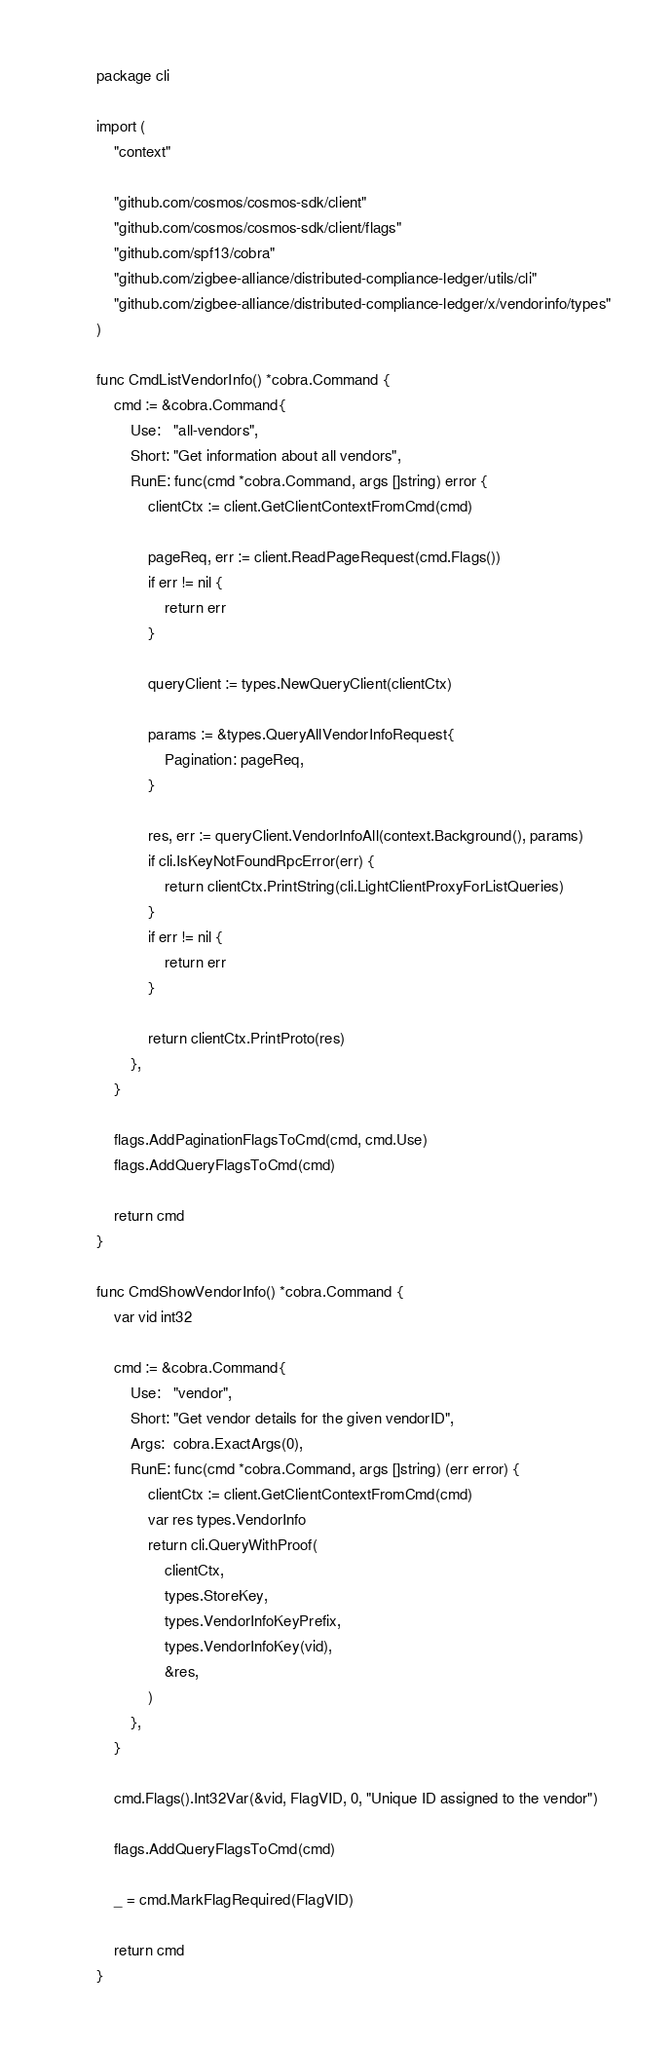<code> <loc_0><loc_0><loc_500><loc_500><_Go_>package cli

import (
	"context"

	"github.com/cosmos/cosmos-sdk/client"
	"github.com/cosmos/cosmos-sdk/client/flags"
	"github.com/spf13/cobra"
	"github.com/zigbee-alliance/distributed-compliance-ledger/utils/cli"
	"github.com/zigbee-alliance/distributed-compliance-ledger/x/vendorinfo/types"
)

func CmdListVendorInfo() *cobra.Command {
	cmd := &cobra.Command{
		Use:   "all-vendors",
		Short: "Get information about all vendors",
		RunE: func(cmd *cobra.Command, args []string) error {
			clientCtx := client.GetClientContextFromCmd(cmd)

			pageReq, err := client.ReadPageRequest(cmd.Flags())
			if err != nil {
				return err
			}

			queryClient := types.NewQueryClient(clientCtx)

			params := &types.QueryAllVendorInfoRequest{
				Pagination: pageReq,
			}

			res, err := queryClient.VendorInfoAll(context.Background(), params)
			if cli.IsKeyNotFoundRpcError(err) {
				return clientCtx.PrintString(cli.LightClientProxyForListQueries)
			}
			if err != nil {
				return err
			}

			return clientCtx.PrintProto(res)
		},
	}

	flags.AddPaginationFlagsToCmd(cmd, cmd.Use)
	flags.AddQueryFlagsToCmd(cmd)

	return cmd
}

func CmdShowVendorInfo() *cobra.Command {
	var vid int32

	cmd := &cobra.Command{
		Use:   "vendor",
		Short: "Get vendor details for the given vendorID",
		Args:  cobra.ExactArgs(0),
		RunE: func(cmd *cobra.Command, args []string) (err error) {
			clientCtx := client.GetClientContextFromCmd(cmd)
			var res types.VendorInfo
			return cli.QueryWithProof(
				clientCtx,
				types.StoreKey,
				types.VendorInfoKeyPrefix,
				types.VendorInfoKey(vid),
				&res,
			)
		},
	}

	cmd.Flags().Int32Var(&vid, FlagVID, 0, "Unique ID assigned to the vendor")

	flags.AddQueryFlagsToCmd(cmd)

	_ = cmd.MarkFlagRequired(FlagVID)

	return cmd
}
</code> 